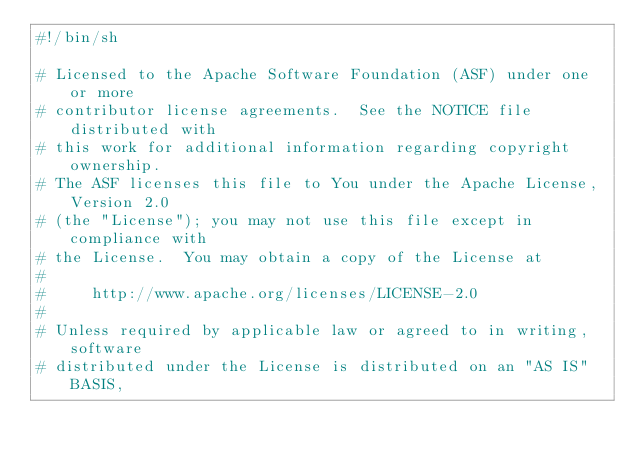Convert code to text. <code><loc_0><loc_0><loc_500><loc_500><_Bash_>#!/bin/sh

# Licensed to the Apache Software Foundation (ASF) under one or more
# contributor license agreements.  See the NOTICE file distributed with
# this work for additional information regarding copyright ownership.
# The ASF licenses this file to You under the Apache License, Version 2.0
# (the "License"); you may not use this file except in compliance with
# the License.  You may obtain a copy of the License at
#
#     http://www.apache.org/licenses/LICENSE-2.0
#
# Unless required by applicable law or agreed to in writing, software
# distributed under the License is distributed on an "AS IS" BASIS,</code> 